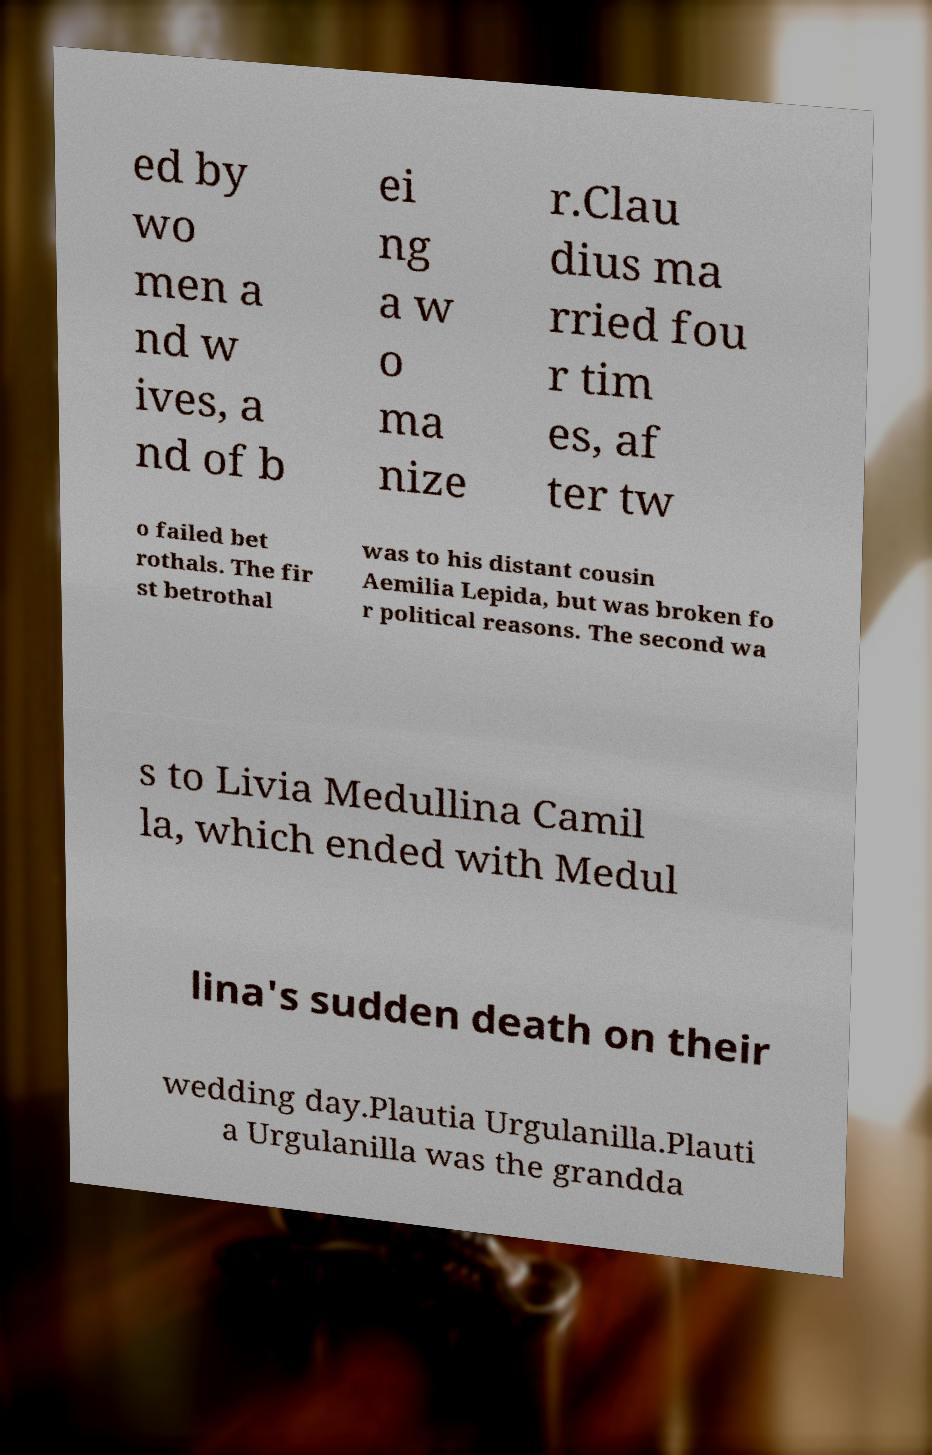Can you read and provide the text displayed in the image?This photo seems to have some interesting text. Can you extract and type it out for me? ed by wo men a nd w ives, a nd of b ei ng a w o ma nize r.Clau dius ma rried fou r tim es, af ter tw o failed bet rothals. The fir st betrothal was to his distant cousin Aemilia Lepida, but was broken fo r political reasons. The second wa s to Livia Medullina Camil la, which ended with Medul lina's sudden death on their wedding day.Plautia Urgulanilla.Plauti a Urgulanilla was the grandda 